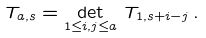Convert formula to latex. <formula><loc_0><loc_0><loc_500><loc_500>T _ { a , s } = \det _ { 1 \leq i , j \leq a } \, T _ { 1 , s + i - j } \, .</formula> 